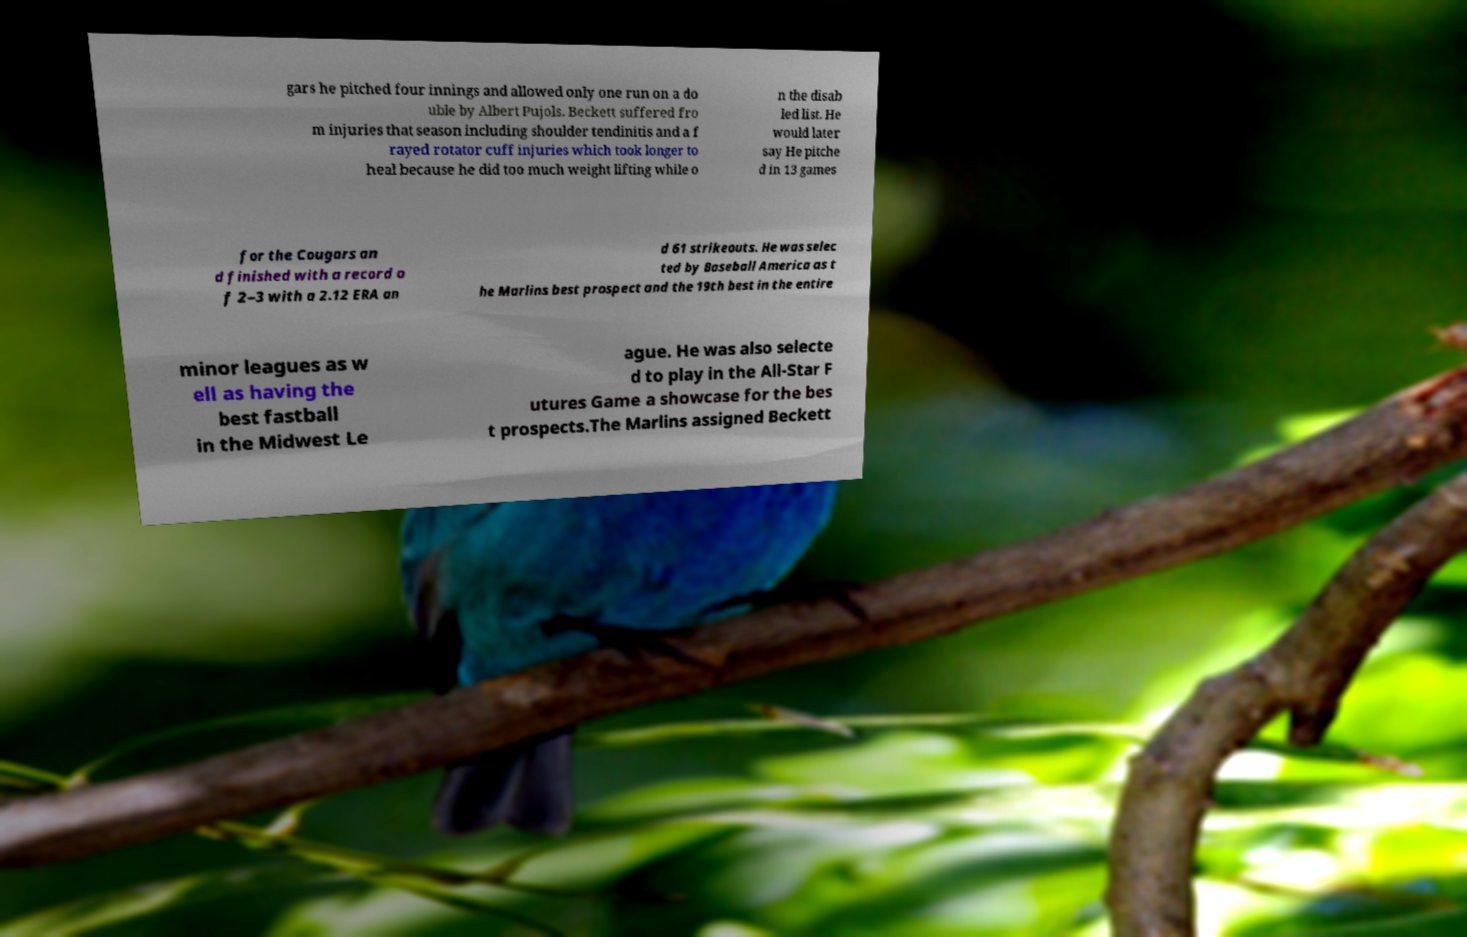There's text embedded in this image that I need extracted. Can you transcribe it verbatim? gars he pitched four innings and allowed only one run on a do uble by Albert Pujols. Beckett suffered fro m injuries that season including shoulder tendinitis and a f rayed rotator cuff injuries which took longer to heal because he did too much weight lifting while o n the disab led list. He would later say He pitche d in 13 games for the Cougars an d finished with a record o f 2–3 with a 2.12 ERA an d 61 strikeouts. He was selec ted by Baseball America as t he Marlins best prospect and the 19th best in the entire minor leagues as w ell as having the best fastball in the Midwest Le ague. He was also selecte d to play in the All-Star F utures Game a showcase for the bes t prospects.The Marlins assigned Beckett 